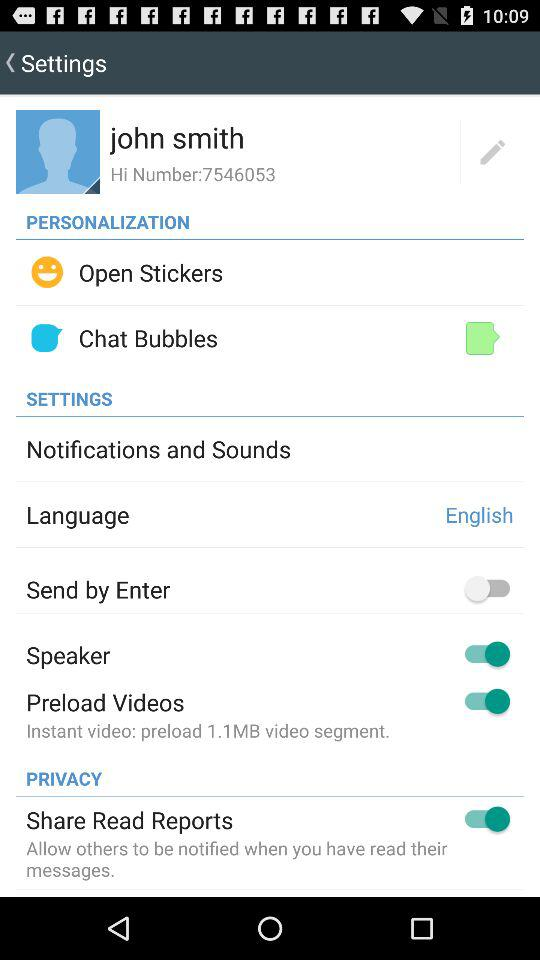Which is the selected language? The selected language is English. 